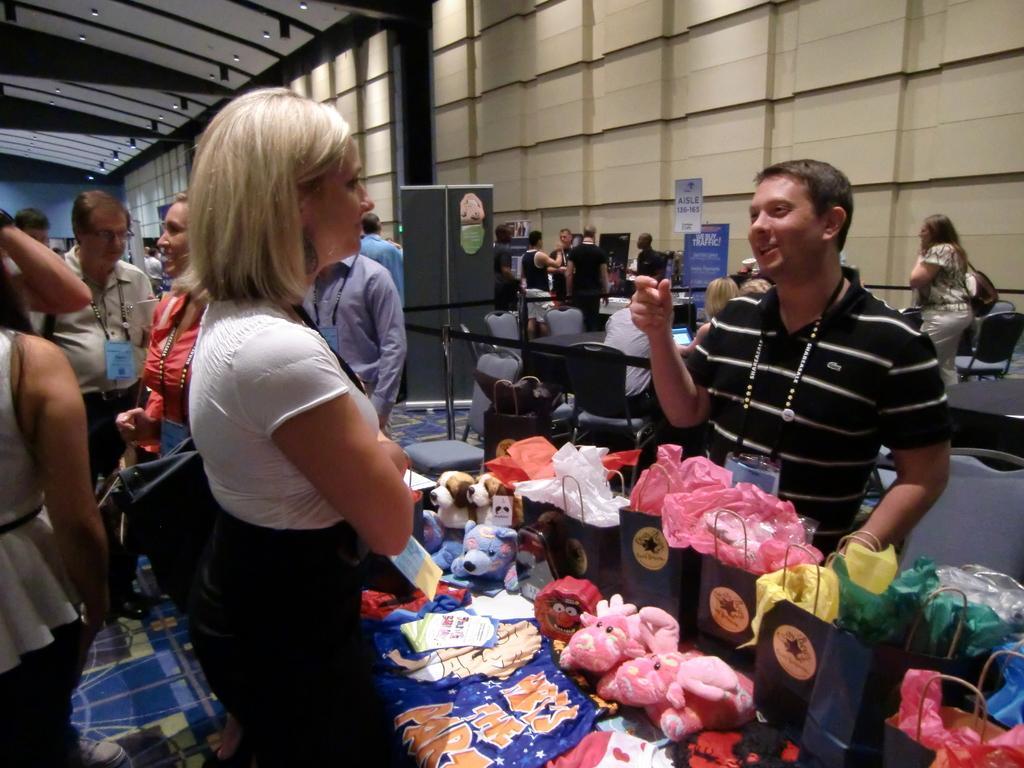Could you give a brief overview of what you see in this image? In the center of the image some persons are standing and toys, bags, boards are there. In the background of the image we can see some persons, chairs, boards, wall. At the top of the image we can see lights, roof. At the bottom of the image there is a floor. 